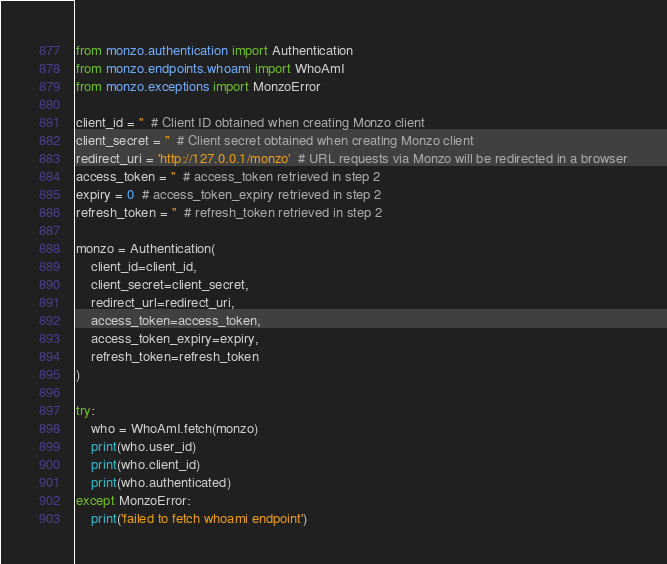Convert code to text. <code><loc_0><loc_0><loc_500><loc_500><_Python_>from monzo.authentication import Authentication
from monzo.endpoints.whoami import WhoAmI
from monzo.exceptions import MonzoError

client_id = ''  # Client ID obtained when creating Monzo client
client_secret = ''  # Client secret obtained when creating Monzo client
redirect_uri = 'http://127.0.0.1/monzo'  # URL requests via Monzo will be redirected in a browser
access_token = ''  # access_token retrieved in step 2
expiry = 0  # access_token_expiry retrieved in step 2
refresh_token = ''  # refresh_token retrieved in step 2

monzo = Authentication(
    client_id=client_id,
    client_secret=client_secret,
    redirect_url=redirect_uri,
    access_token=access_token,
    access_token_expiry=expiry,
    refresh_token=refresh_token
)

try:
    who = WhoAmI.fetch(monzo)
    print(who.user_id)
    print(who.client_id)
    print(who.authenticated)
except MonzoError:
    print('failed to fetch whoami endpoint')
</code> 